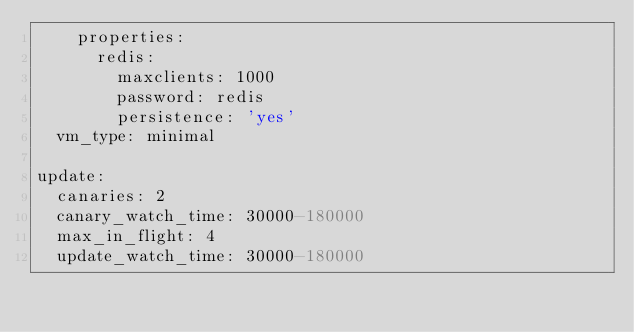Convert code to text. <code><loc_0><loc_0><loc_500><loc_500><_YAML_>    properties:
      redis:
        maxclients: 1000
        password: redis
        persistence: 'yes'
  vm_type: minimal

update:
  canaries: 2
  canary_watch_time: 30000-180000
  max_in_flight: 4
  update_watch_time: 30000-180000
</code> 